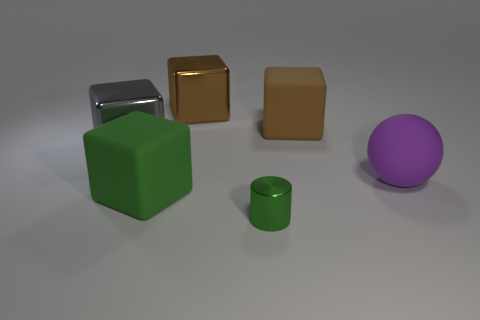Subtract all gray blocks. How many blocks are left? 3 Subtract 2 blocks. How many blocks are left? 2 Add 3 small green objects. How many objects exist? 9 Subtract all yellow blocks. Subtract all red spheres. How many blocks are left? 4 Add 5 spheres. How many spheres are left? 6 Add 6 large purple balls. How many large purple balls exist? 7 Subtract 0 blue cubes. How many objects are left? 6 Subtract all cubes. How many objects are left? 2 Subtract all purple spheres. Subtract all purple rubber balls. How many objects are left? 4 